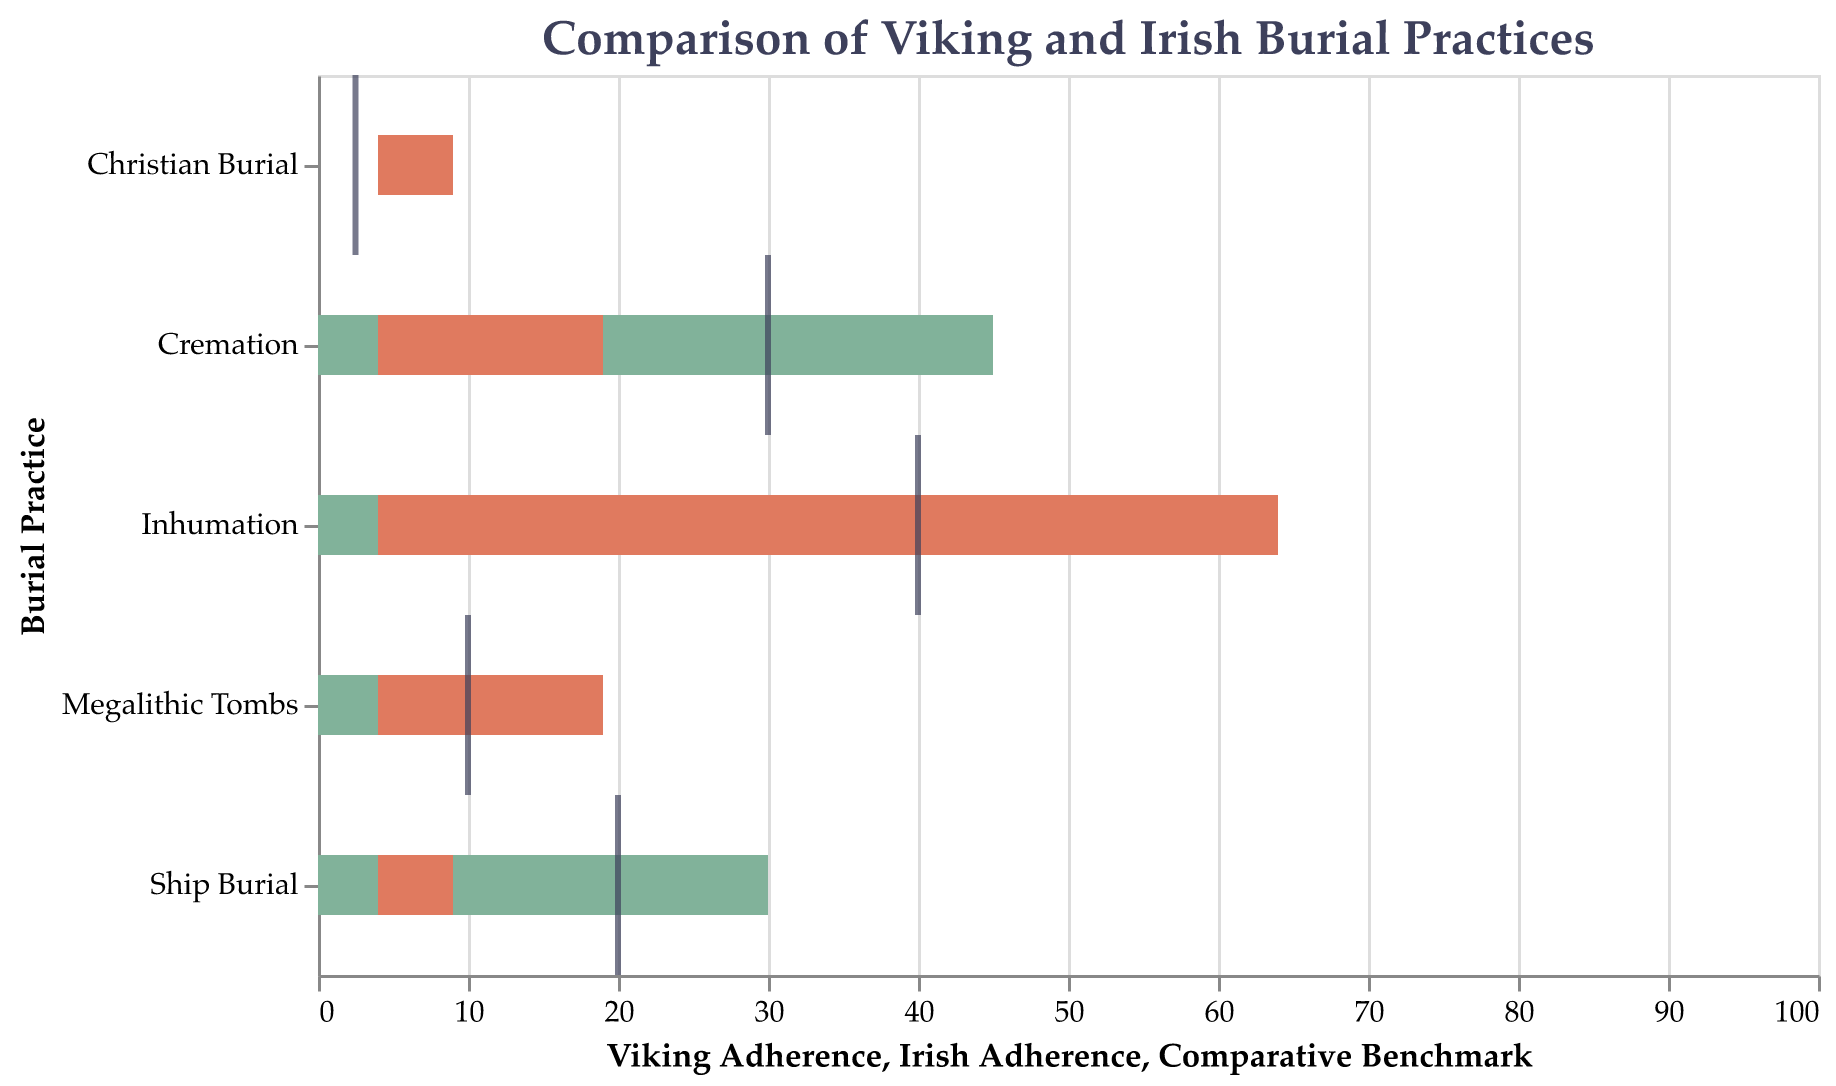What is the title of the figure? The title of the figure is found at the top of the chart and it provides an overview of the main subject.
Answer: Comparison of Viking and Irish Burial Practices Which burial practice has the highest Viking adherence percentage? By examining the lengths of the bars representing Viking adherence, the burial practice with the longest bar should have the highest percentage.
Answer: Cremation What is the comparative benchmark for megalithic tombs? The comparative benchmark is indicated by a tick mark for each burial practice.
Answer: 10% How do Viking and Irish adherence percentages compare for ship burial? The Viking adherence bar is much longer compared to the Irish adherence bar for ship burial.
Answer: Viking adherence is higher By how much does the Irish adherence to inhumation exceed the comparative benchmark? Subtract the comparative benchmark value for inhumation from the Irish adherence percentage.
Answer: 20% What is the sum of Viking adherence percentages for ship burial and cremation? Add the Viking adherence percentages for ship burial and cremation.
Answer: 75% Which burial practice shows the largest difference between Viking and Irish adherence? Calculate the absolute differences between Viking and Irish adherence for each burial practice and identify the largest one.
Answer: Inhumation Based on the figure, which community shows more diversity in burial practices? Considering the range of adherence percentages across different practices for both communities, the community with a higher spread indicates more diversity.
Answer: Irish community What is the average comparative benchmark across all burial practices? Sum up the comparative benchmarks for all practices and divide by the number of practices.
Answer: (20 + 30 + 40 + 10 + 2.5) / 5 = 20.5 Which burial practice has the lowest adherence from both communities? Identify the burial practice with the lowest percentages for both Viking and Irish adherence.
Answer: Christian Burial 